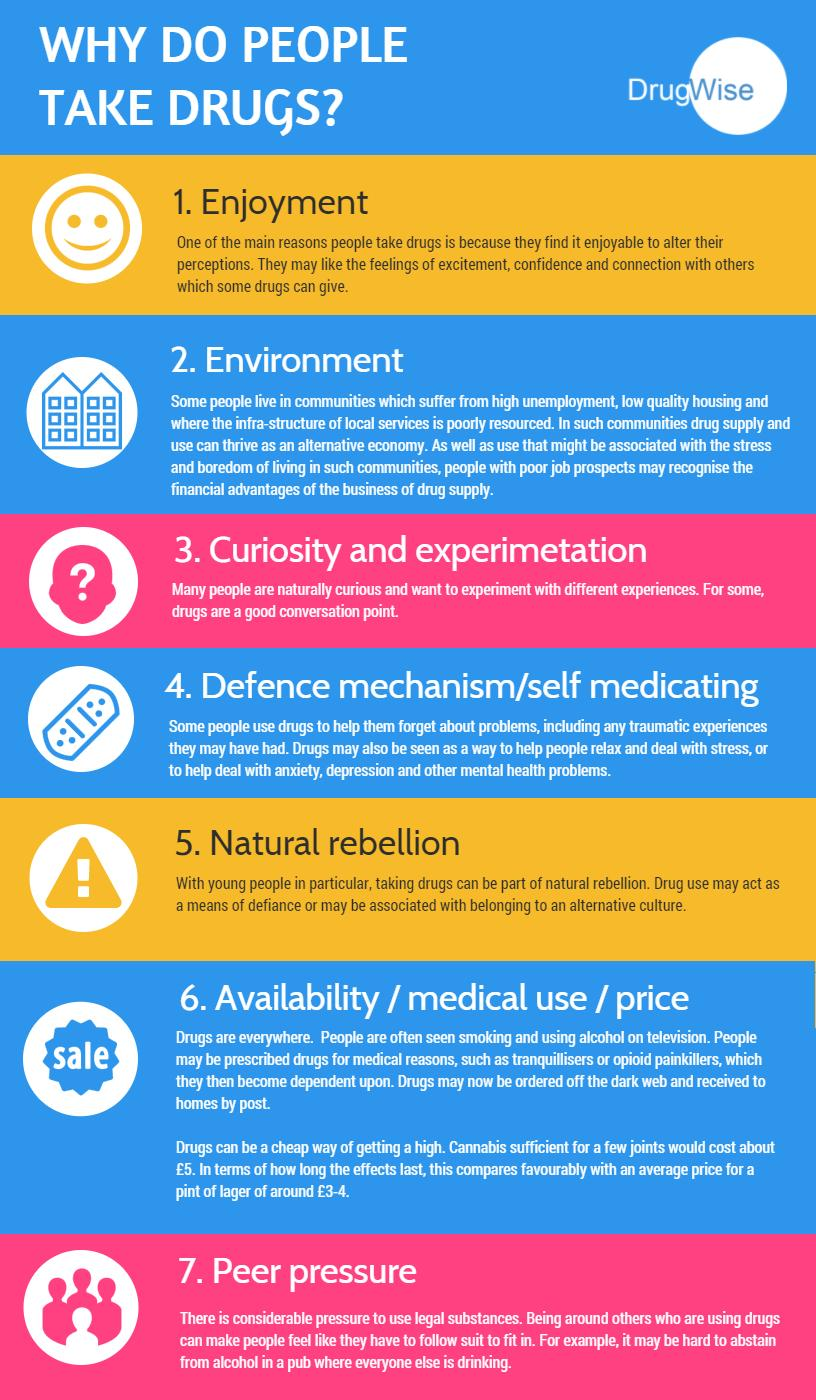List a handful of essential elements in this visual. The infographic lists natural rebellion as the fifth reason why people take drugs. The seventh reason for people to take drugs as listed in the infographic is peer pressure. 